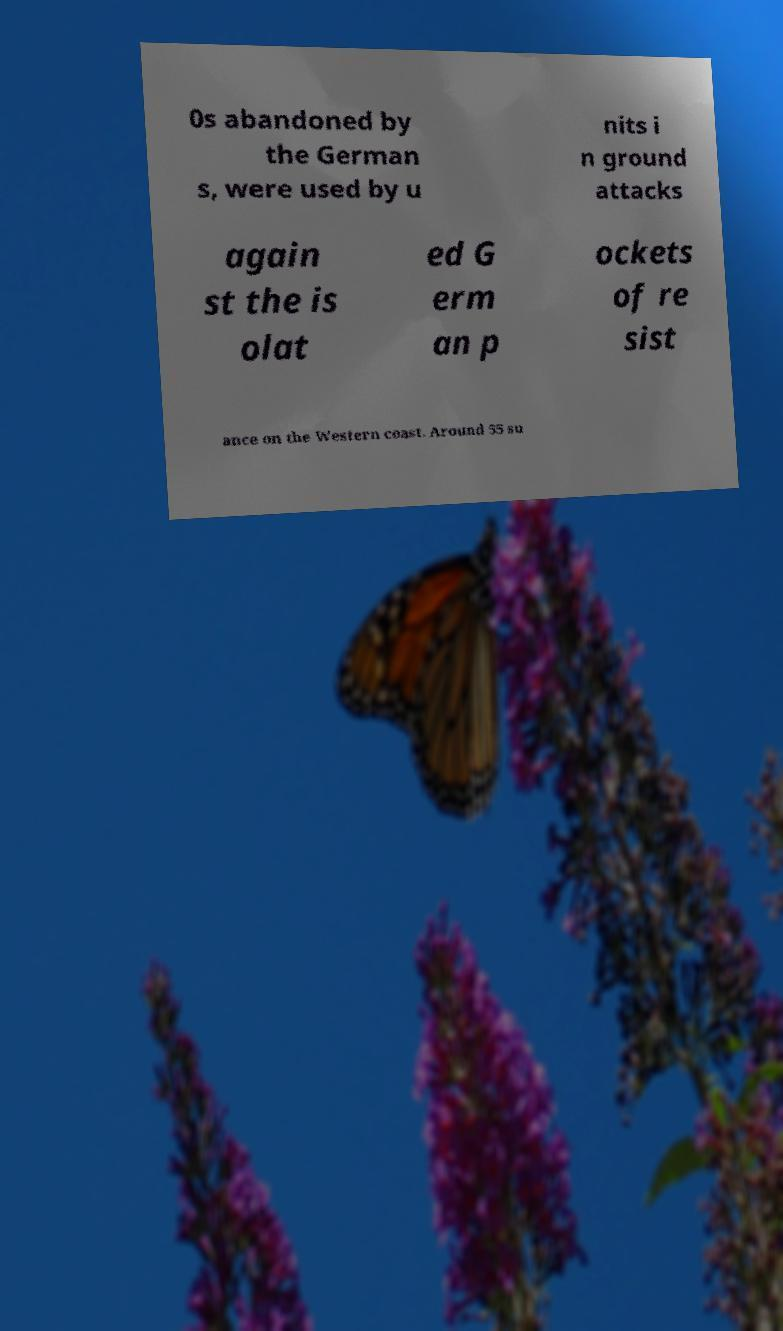Can you read and provide the text displayed in the image?This photo seems to have some interesting text. Can you extract and type it out for me? 0s abandoned by the German s, were used by u nits i n ground attacks again st the is olat ed G erm an p ockets of re sist ance on the Western coast. Around 55 su 